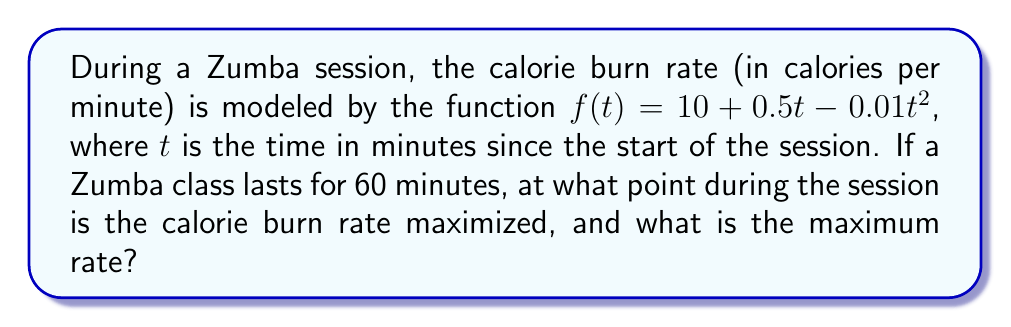Show me your answer to this math problem. To solve this optimization problem, we need to follow these steps:

1) The function $f(t) = 10 + 0.5t - 0.01t^2$ represents the calorie burn rate at time $t$.

2) To find the maximum, we need to find the critical points by taking the derivative and setting it to zero:

   $f'(t) = 0.5 - 0.02t$

3) Set $f'(t) = 0$:

   $0.5 - 0.02t = 0$
   $0.5 = 0.02t$
   $t = 25$

4) To confirm this is a maximum (not a minimum), we can check the second derivative:

   $f''(t) = -0.02$

   Since $f''(t)$ is negative, the critical point at $t=25$ is indeed a maximum.

5) The maximum occurs at 25 minutes into the session. To find the maximum rate, we plug this value back into the original function:

   $f(25) = 10 + 0.5(25) - 0.01(25)^2$
          $= 10 + 12.5 - 6.25$
          $= 16.25$

Therefore, the calorie burn rate is maximized 25 minutes into the session, at a rate of 16.25 calories per minute.
Answer: The calorie burn rate is maximized 25 minutes into the session, at a rate of 16.25 calories per minute. 